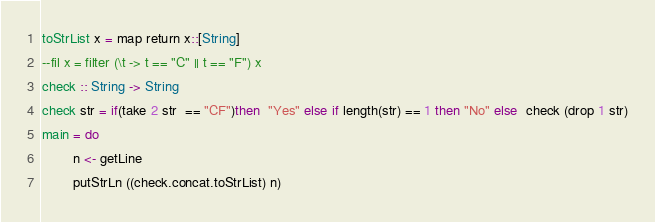<code> <loc_0><loc_0><loc_500><loc_500><_Haskell_>toStrList x = map return x::[String]
--fil x = filter (\t -> t == "C" || t == "F") x
check :: String -> String
check str = if(take 2 str  == "CF")then  "Yes" else if length(str) == 1 then "No" else  check (drop 1 str)
main = do
        n <- getLine
        putStrLn ((check.concat.toStrList) n)</code> 